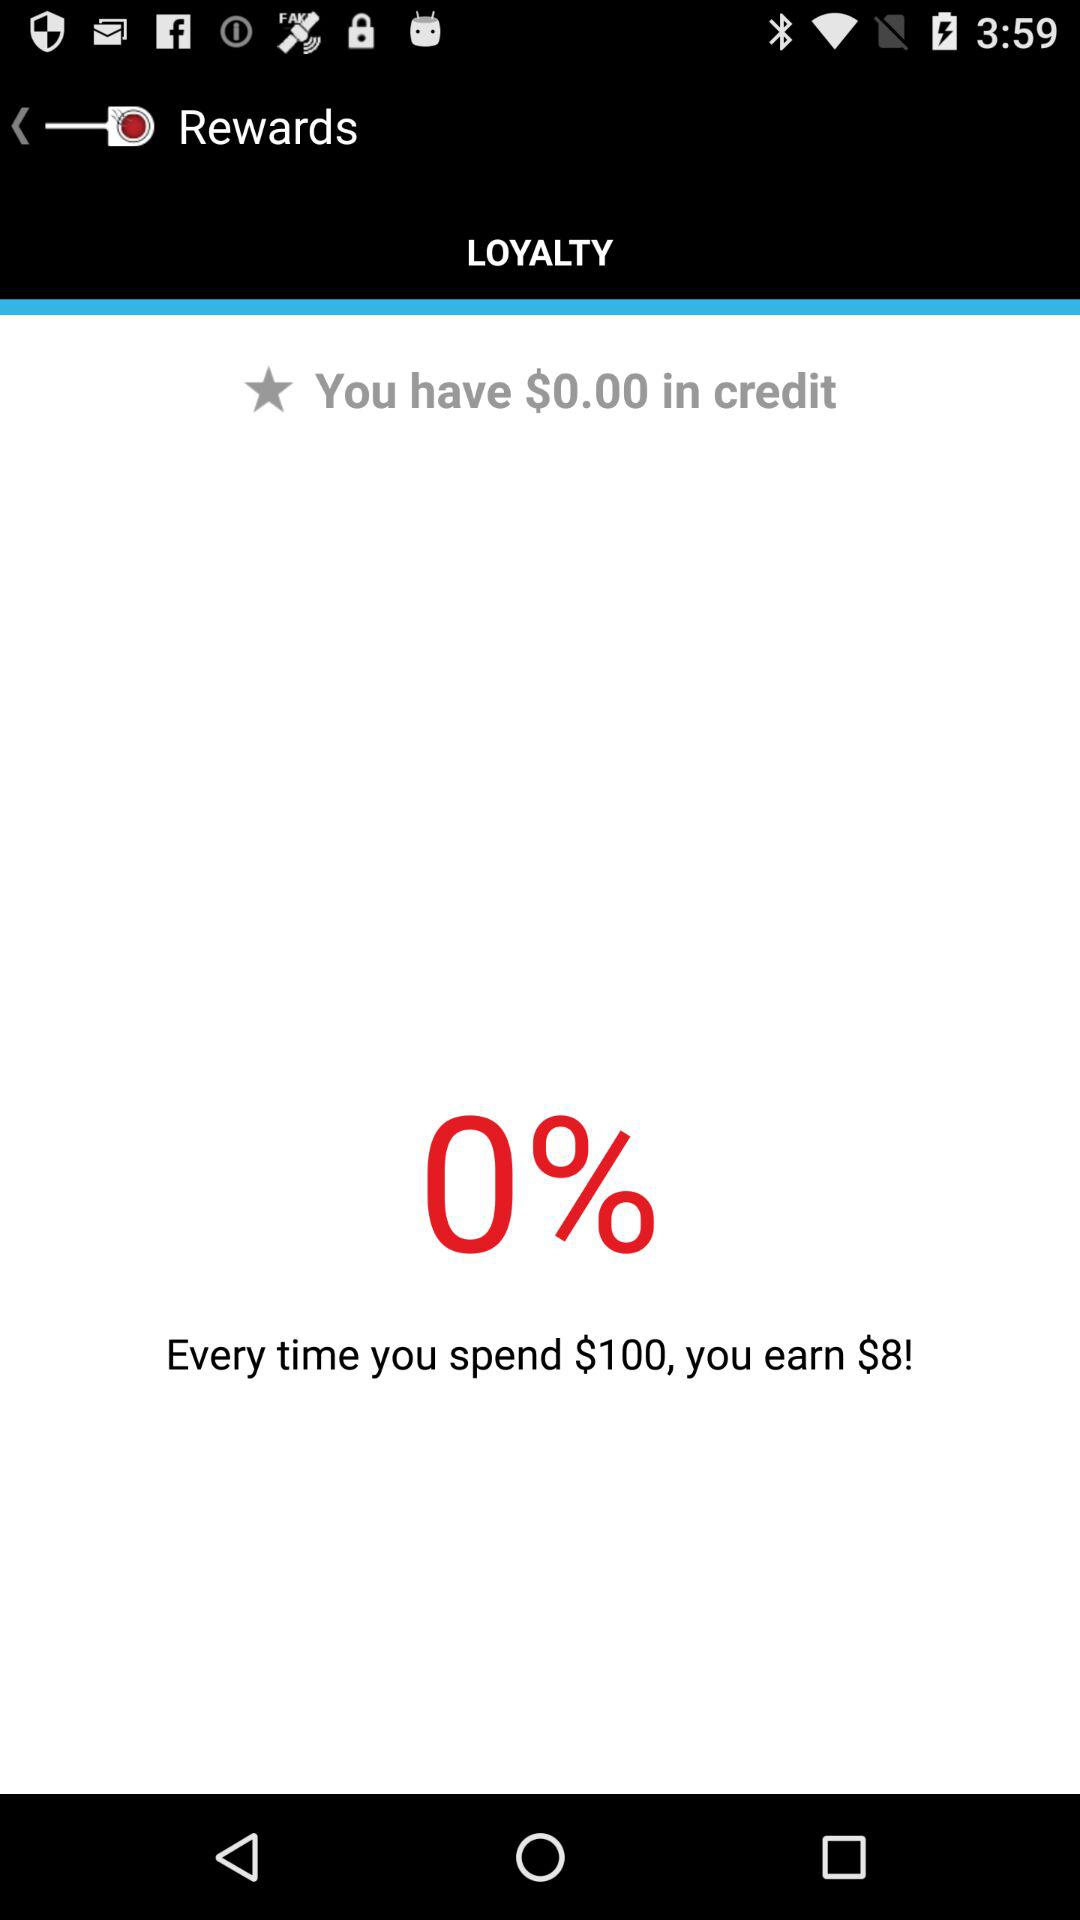How much amount do you earn every time? We earn $8 every time. 